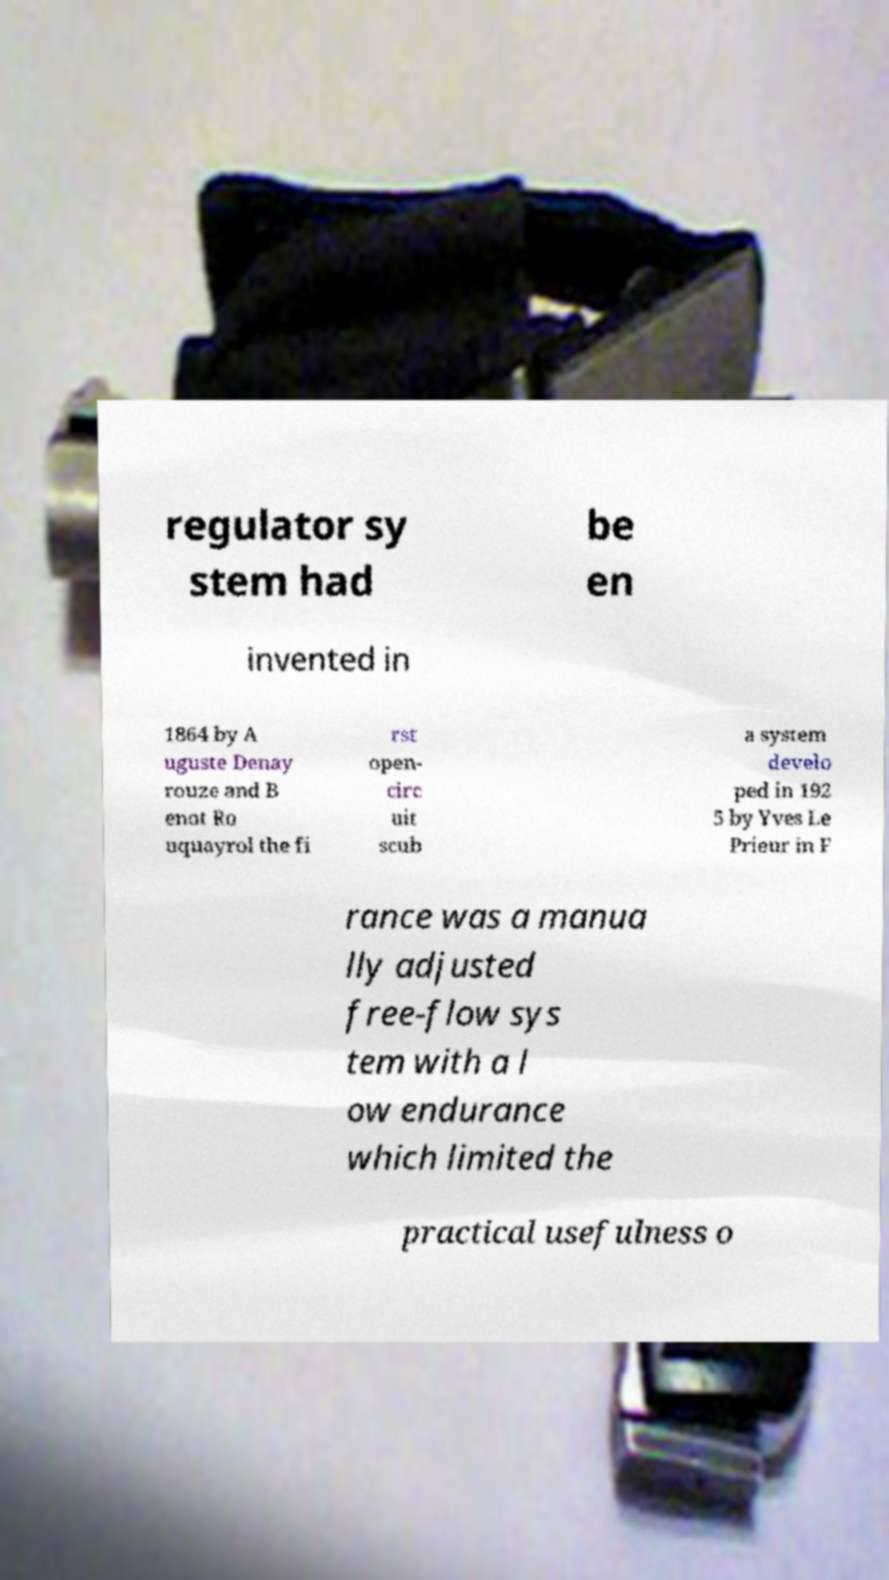What messages or text are displayed in this image? I need them in a readable, typed format. regulator sy stem had be en invented in 1864 by A uguste Denay rouze and B enot Ro uquayrol the fi rst open- circ uit scub a system develo ped in 192 5 by Yves Le Prieur in F rance was a manua lly adjusted free-flow sys tem with a l ow endurance which limited the practical usefulness o 